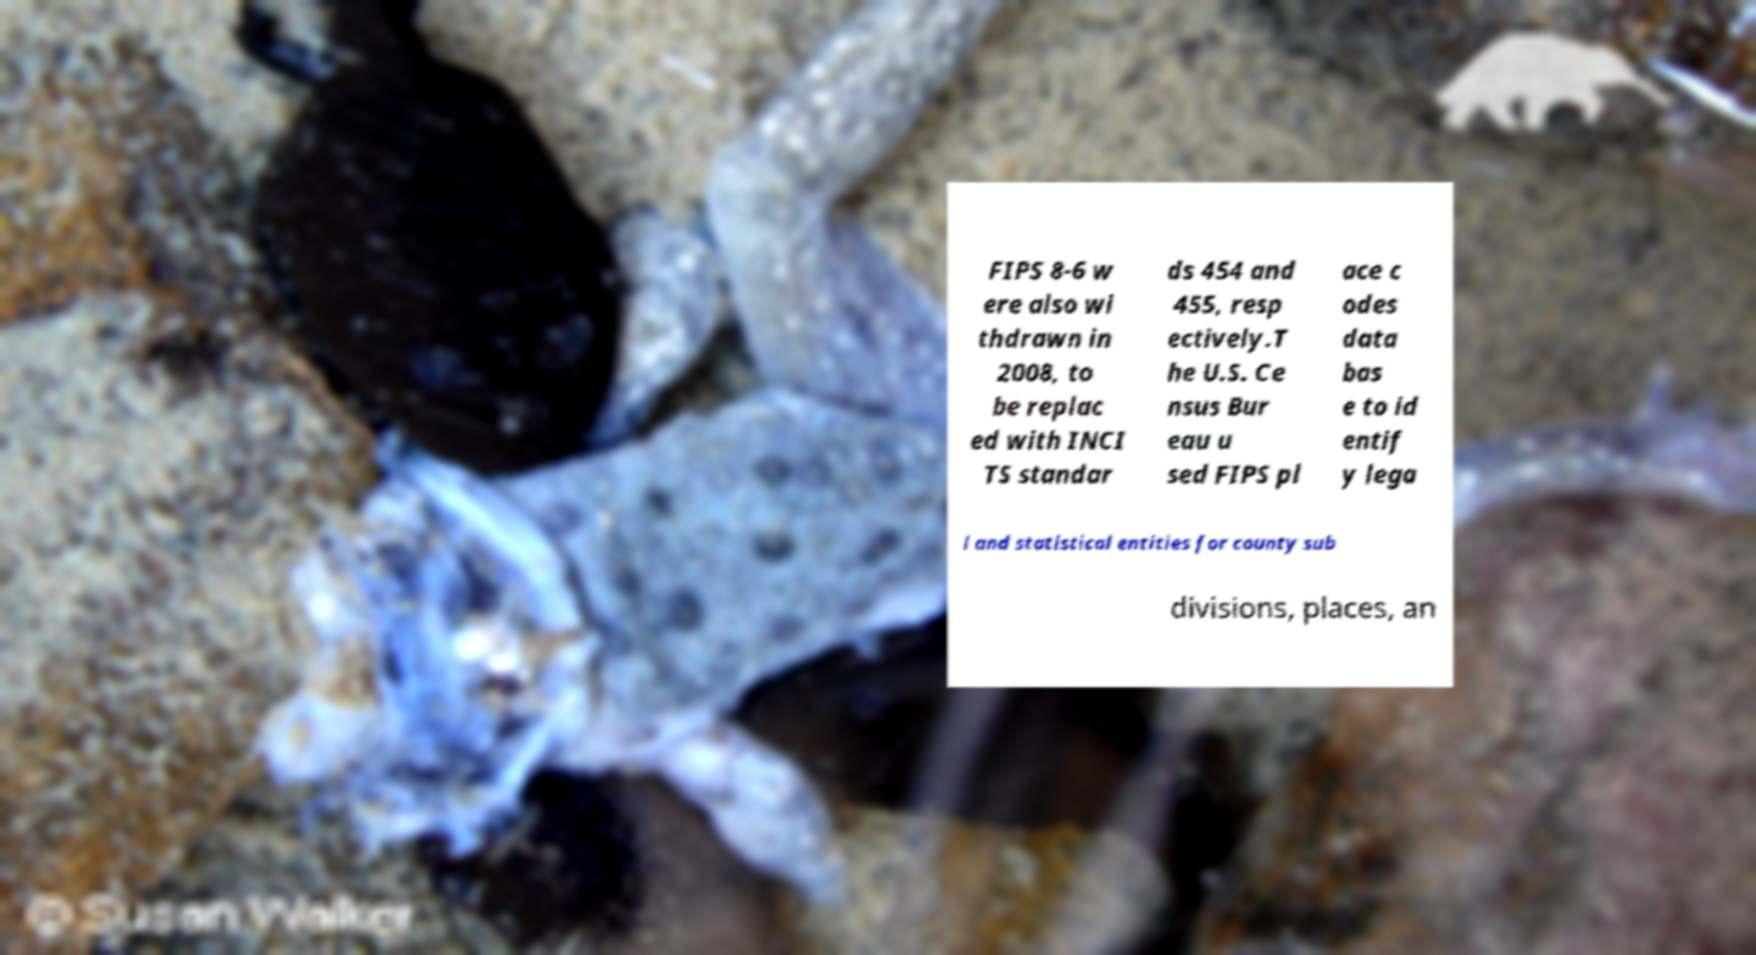I need the written content from this picture converted into text. Can you do that? FIPS 8-6 w ere also wi thdrawn in 2008, to be replac ed with INCI TS standar ds 454 and 455, resp ectively.T he U.S. Ce nsus Bur eau u sed FIPS pl ace c odes data bas e to id entif y lega l and statistical entities for county sub divisions, places, an 